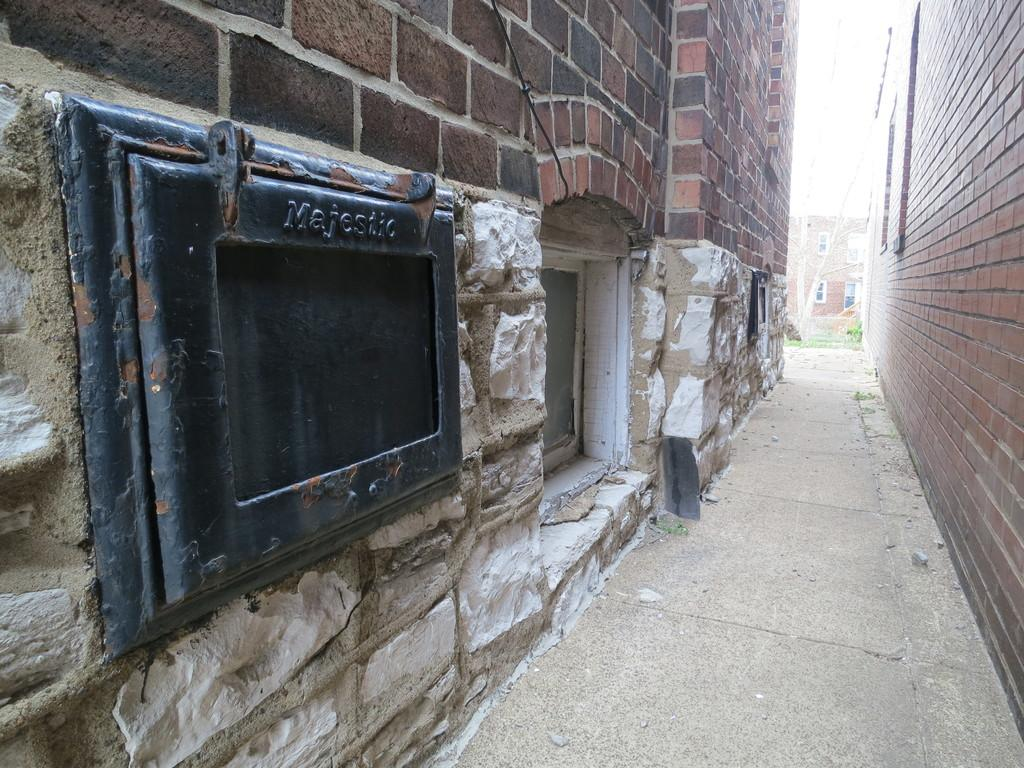What is the main feature in the middle of the image? There is a path in the middle of the image. What can be seen on either side of the path? Buildings are present on either side of the path. Is there anything else visible in the background of the image? Yes, there is another building in the background of the image. What type of shoe is the dog wearing in the image? There is no dog or shoe present in the image. 